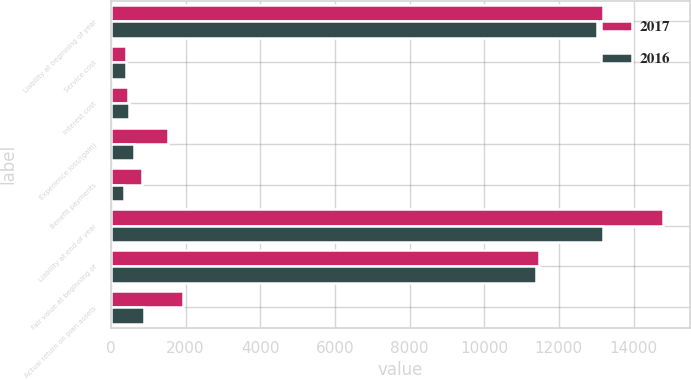<chart> <loc_0><loc_0><loc_500><loc_500><stacked_bar_chart><ecel><fcel>Liability at beginning of year<fcel>Service cost<fcel>Interest cost<fcel>Experience loss/(gain)<fcel>Benefit payments<fcel>Liability at end of year<fcel>Fair value at beginning of<fcel>Actual return on plan assets<nl><fcel>2017<fcel>13192<fcel>401<fcel>468<fcel>1529<fcel>825<fcel>14777<fcel>11458<fcel>1935<nl><fcel>2016<fcel>13033<fcel>393<fcel>484<fcel>614<fcel>347<fcel>13192<fcel>11397<fcel>880<nl></chart> 